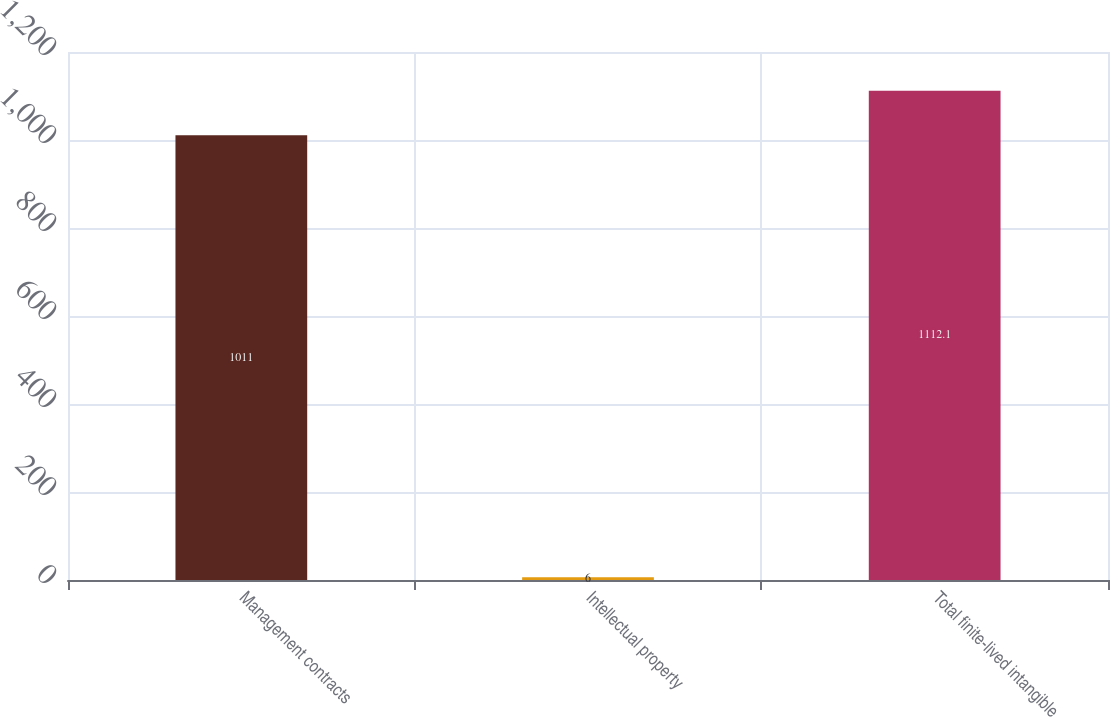Convert chart. <chart><loc_0><loc_0><loc_500><loc_500><bar_chart><fcel>Management contracts<fcel>Intellectual property<fcel>Total finite-lived intangible<nl><fcel>1011<fcel>6<fcel>1112.1<nl></chart> 